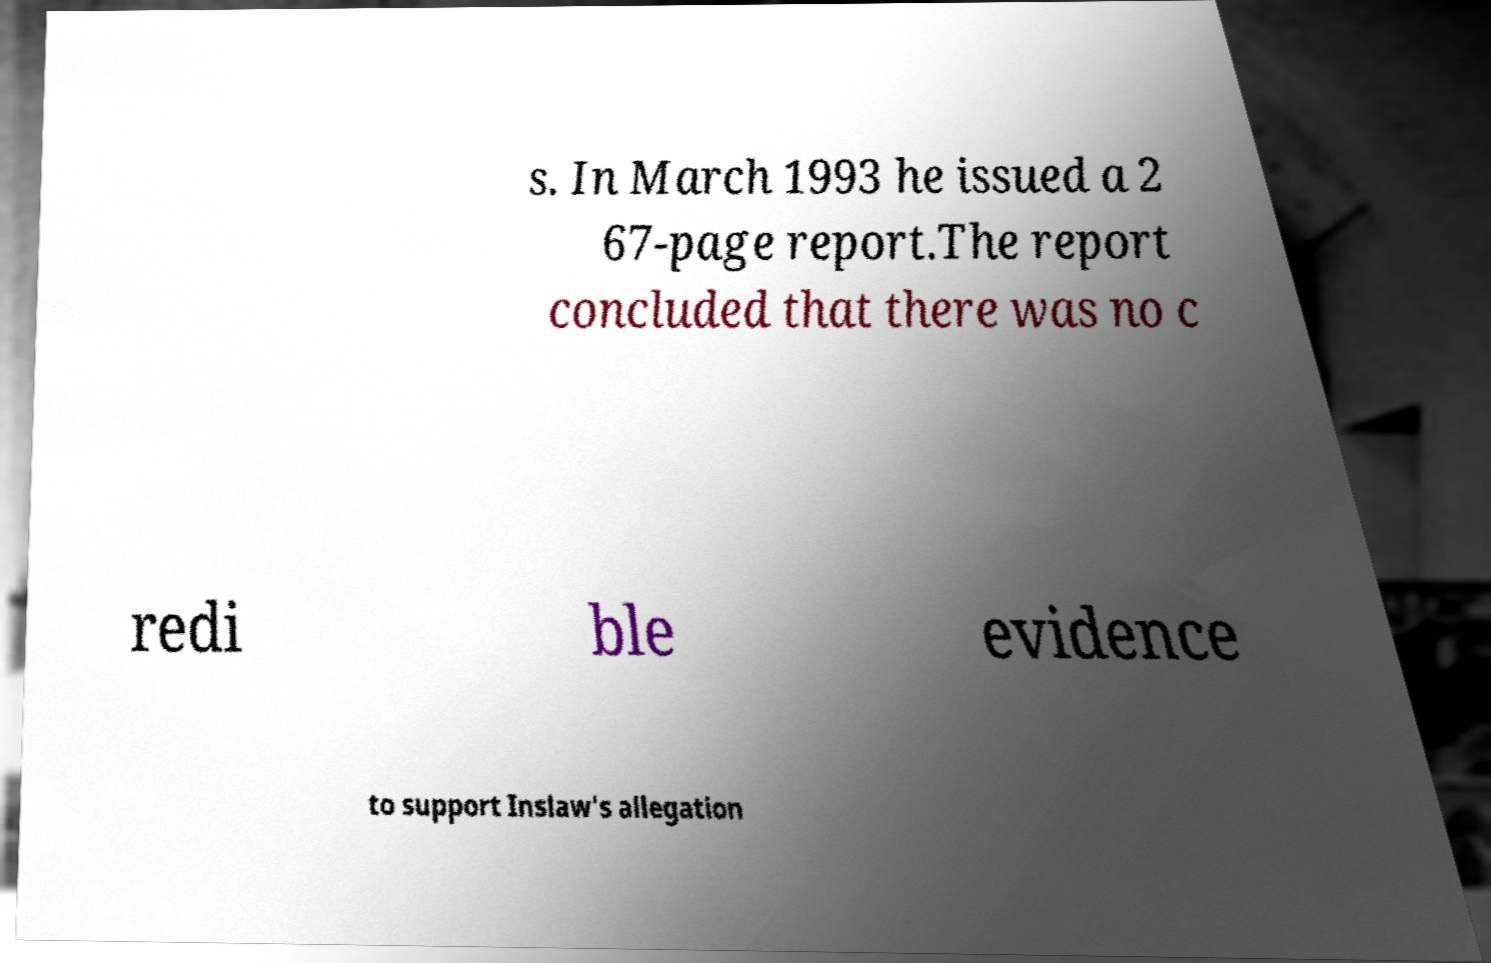Please identify and transcribe the text found in this image. s. In March 1993 he issued a 2 67-page report.The report concluded that there was no c redi ble evidence to support Inslaw's allegation 